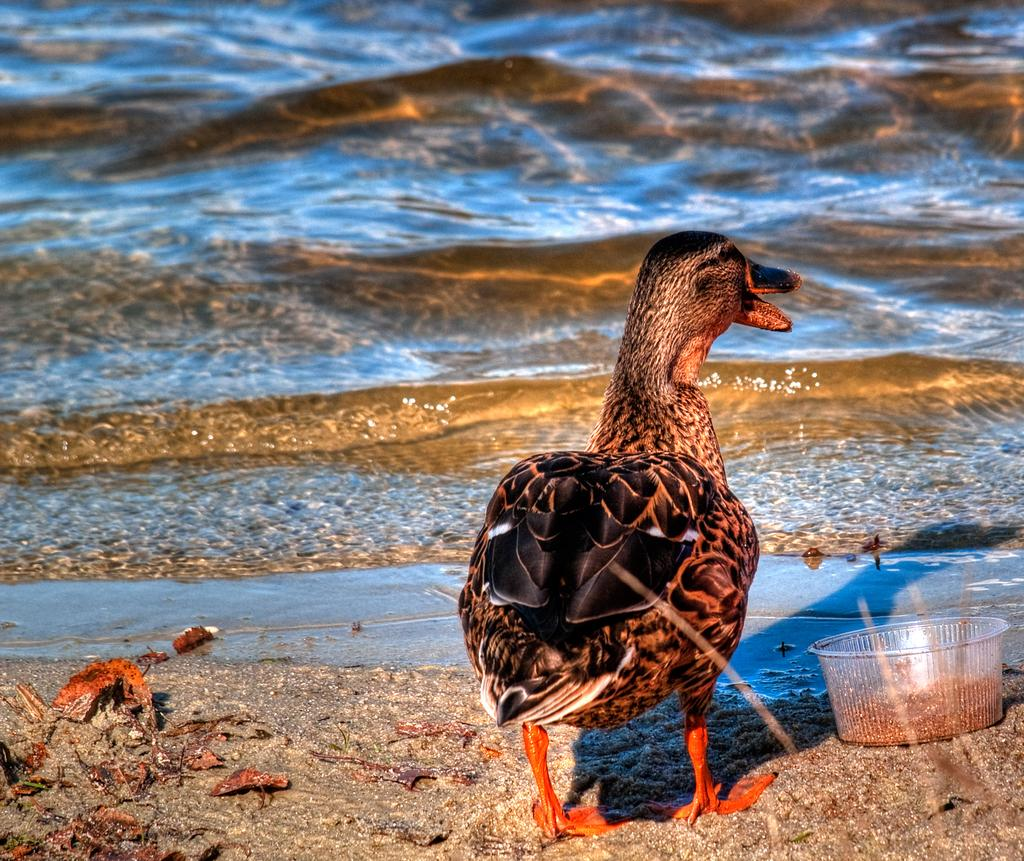What animal is present in the picture? There is a hen in the picture. Where is the hen located in relation to the water? The hen is in front of the water. What can be found in the bowl in the picture? There is a bowl with food in the picture. What type of game is the hen playing in the picture? There is no game present in the image; the hen is simply standing in front of the water. 